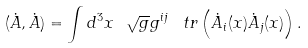<formula> <loc_0><loc_0><loc_500><loc_500>( { \dot { A } } , { \dot { A } } ) = \int d ^ { 3 } x \ \sqrt { g } g ^ { i j } \, \ t r \left ( { \dot { A } _ { i } ( x ) } { \dot { A } _ { j } ( x ) } \right ) .</formula> 